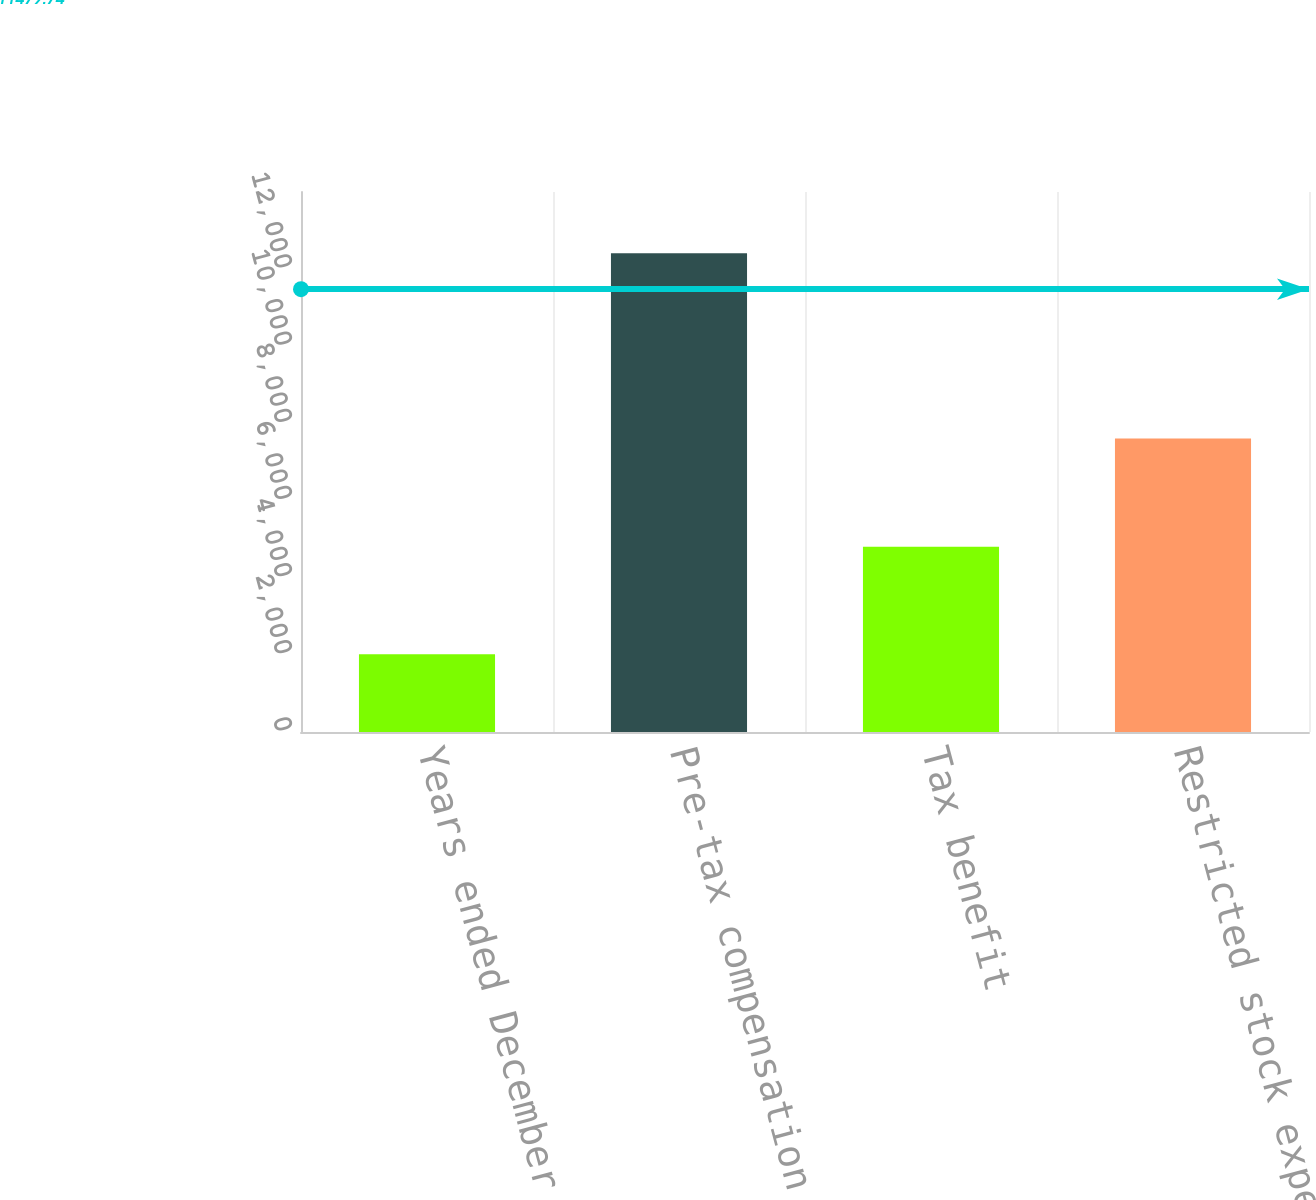<chart> <loc_0><loc_0><loc_500><loc_500><bar_chart><fcel>Years ended December 31<fcel>Pre-tax compensation expense<fcel>Tax benefit<fcel>Restricted stock expense net<nl><fcel>2016<fcel>12415<fcel>4805<fcel>7610<nl></chart> 